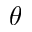<formula> <loc_0><loc_0><loc_500><loc_500>\theta</formula> 